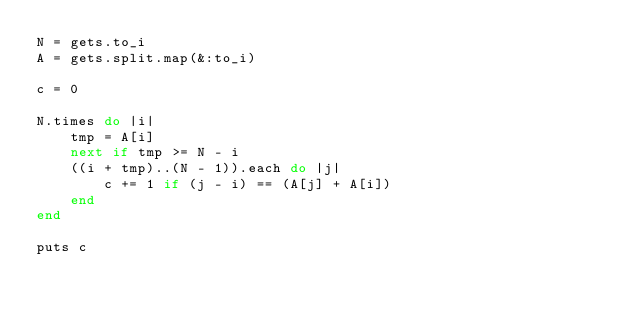<code> <loc_0><loc_0><loc_500><loc_500><_Ruby_>N = gets.to_i
A = gets.split.map(&:to_i)

c = 0

N.times do |i|
    tmp = A[i]
    next if tmp >= N - i
    ((i + tmp)..(N - 1)).each do |j|
        c += 1 if (j - i) == (A[j] + A[i])
    end
end

puts c
</code> 